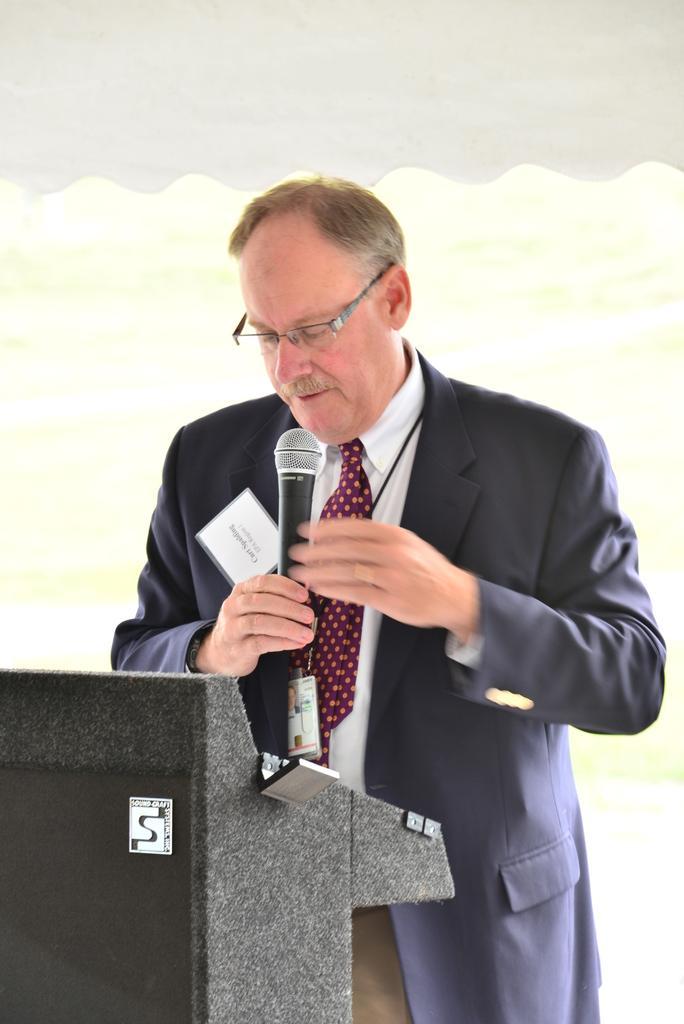In one or two sentences, can you explain what this image depicts? In this image there is a man standing and talking in a microphone near the podium. 